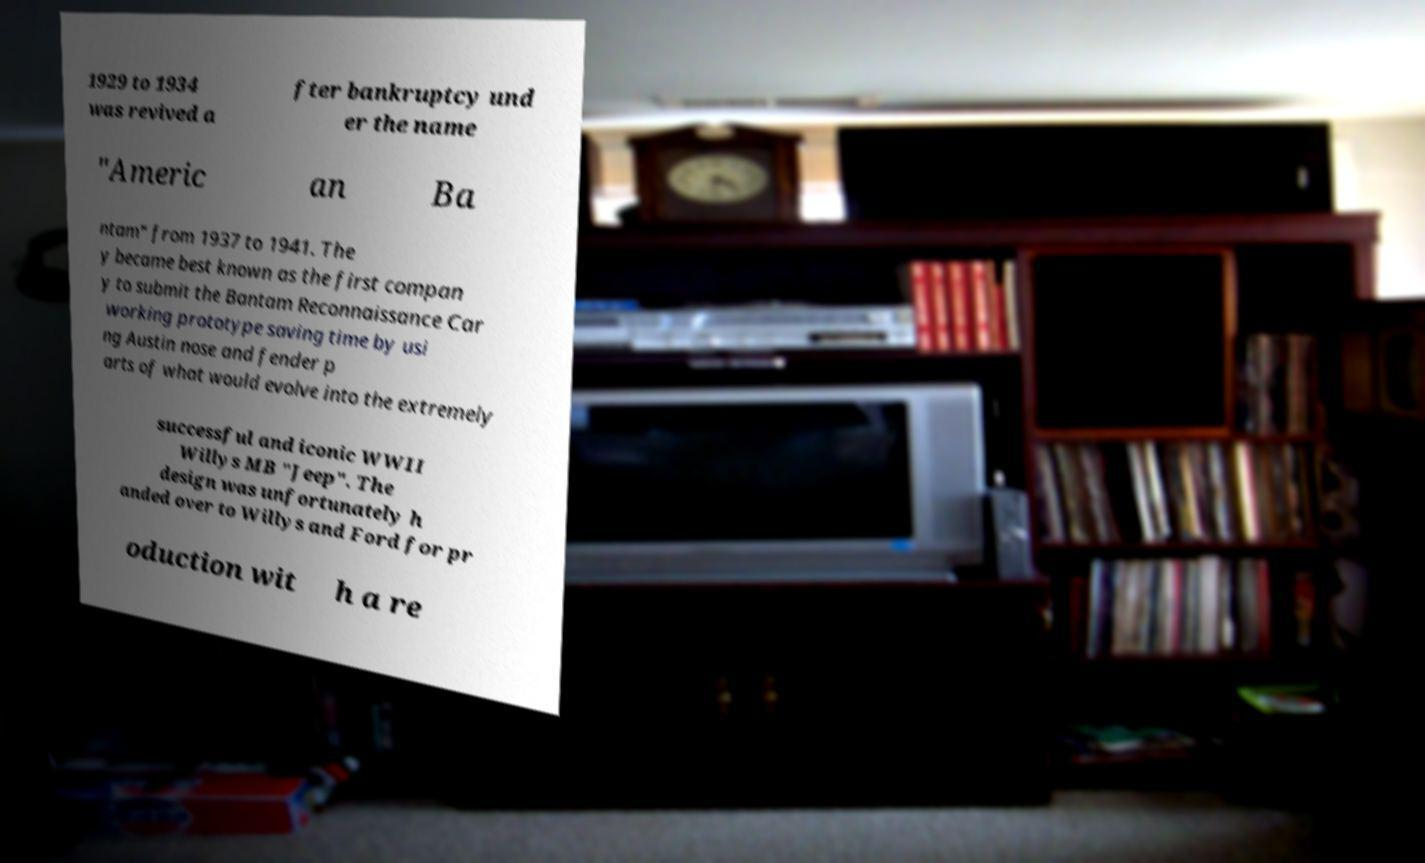What messages or text are displayed in this image? I need them in a readable, typed format. 1929 to 1934 was revived a fter bankruptcy und er the name "Americ an Ba ntam" from 1937 to 1941. The y became best known as the first compan y to submit the Bantam Reconnaissance Car working prototype saving time by usi ng Austin nose and fender p arts of what would evolve into the extremely successful and iconic WWII Willys MB "Jeep". The design was unfortunately h anded over to Willys and Ford for pr oduction wit h a re 